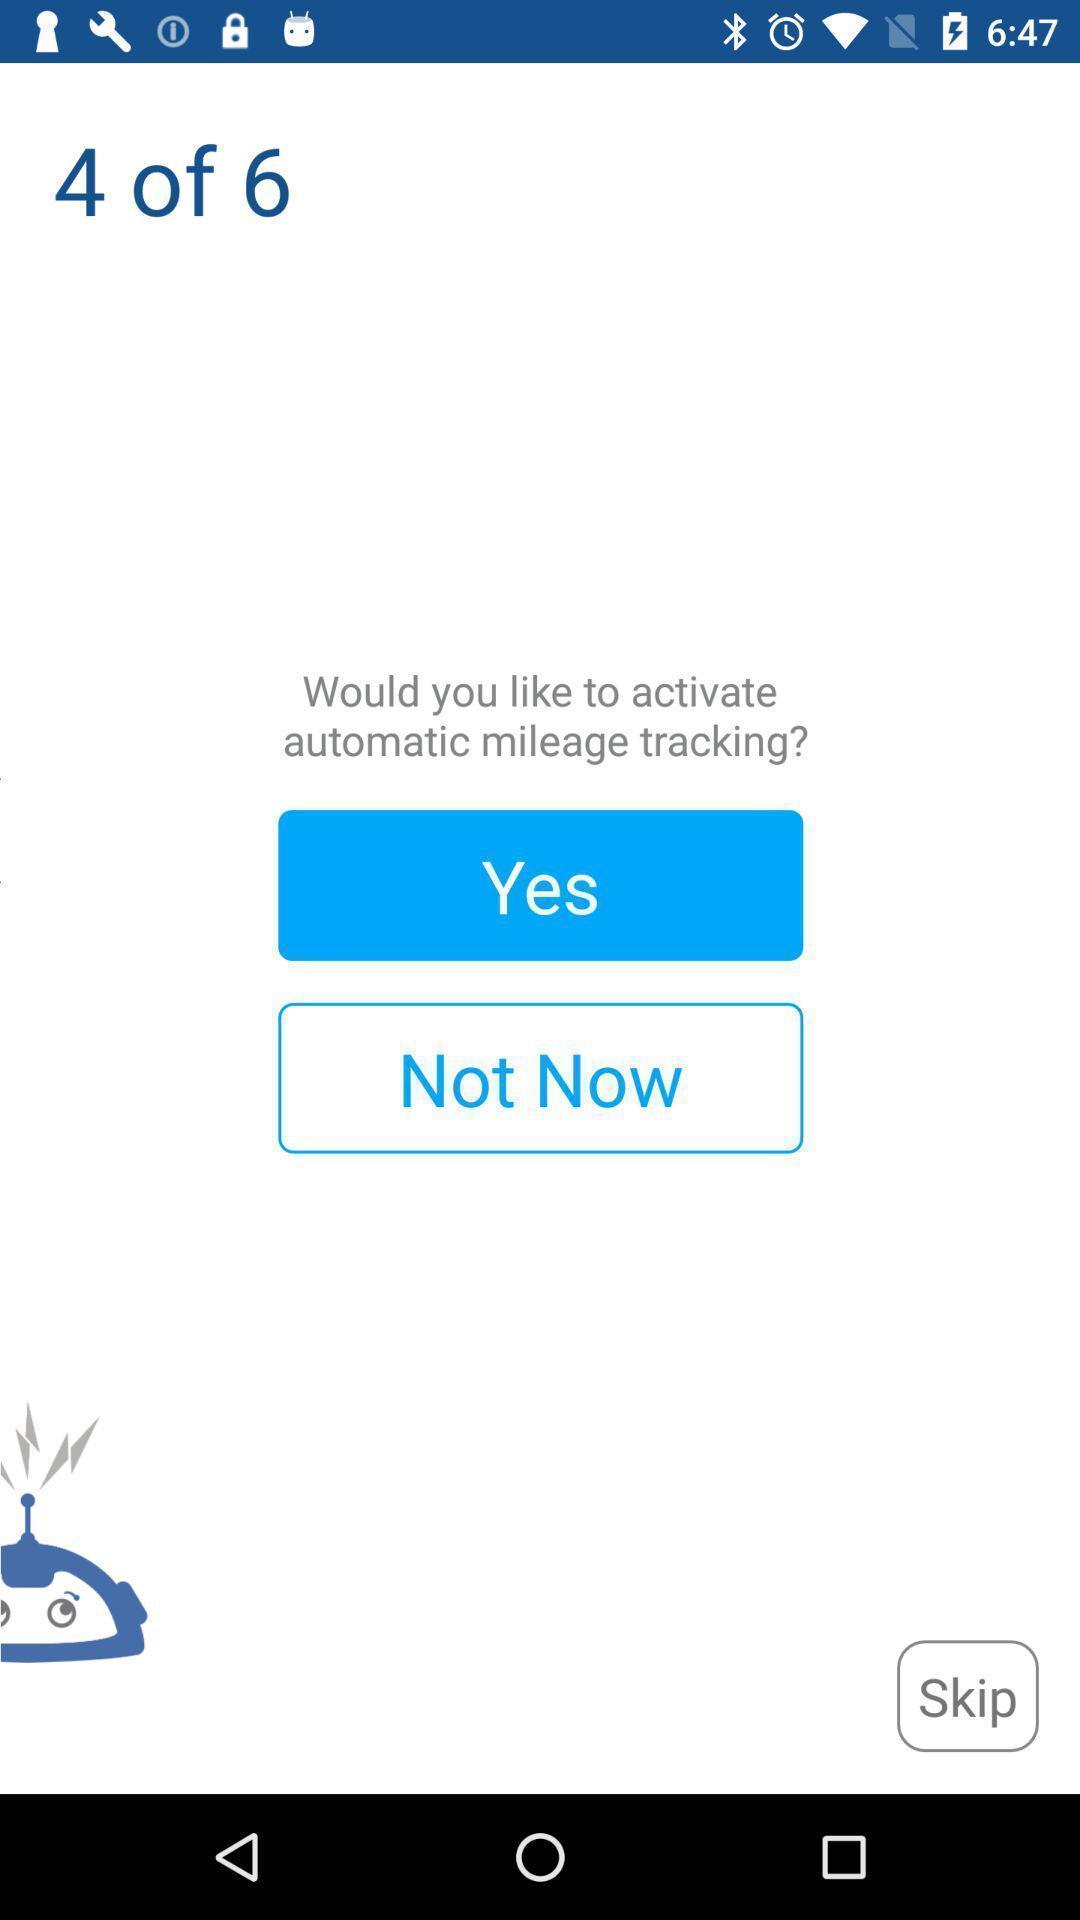Give me a narrative description of this picture. Page seeking permission for mileage tracking. 